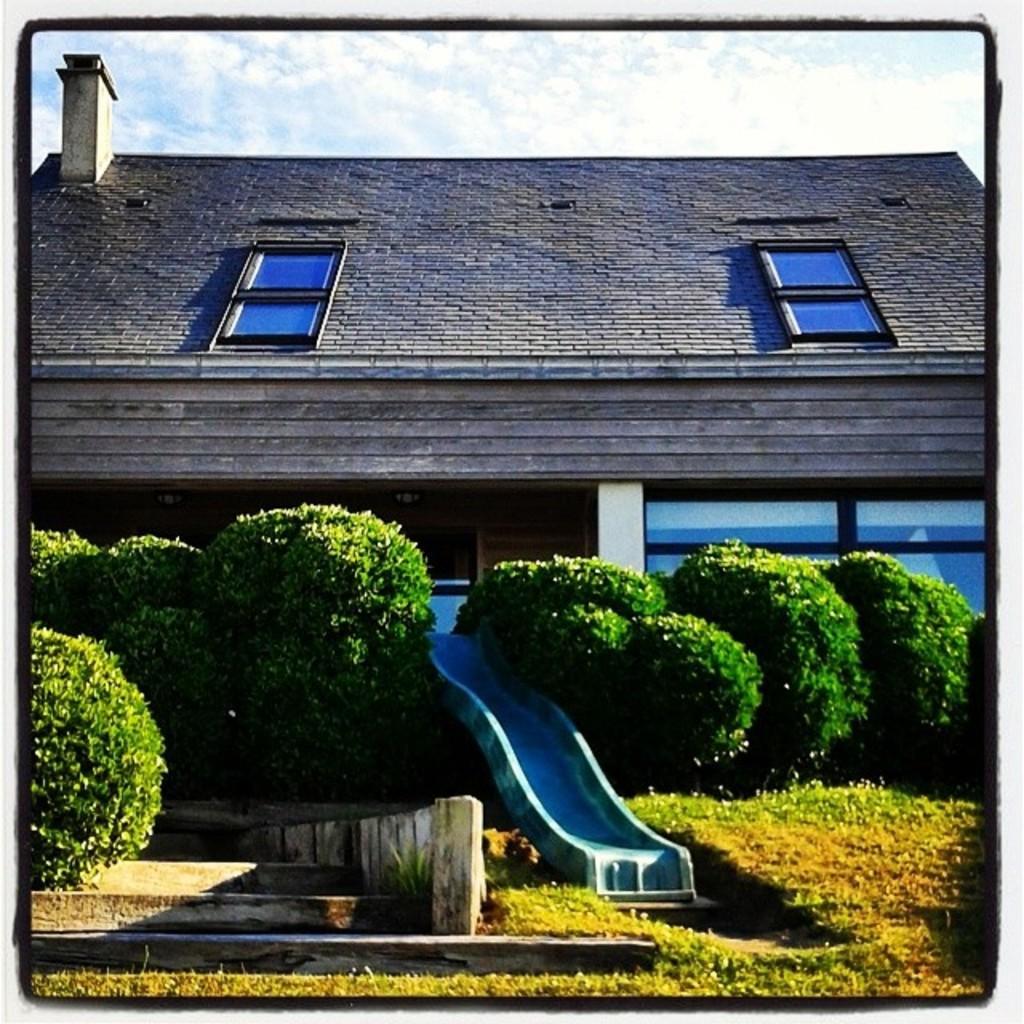In one or two sentences, can you explain what this image depicts? In this picture we can see some plants at the bottom, on the left side there are stars, we can see a slider in the middle, in the background there is a house, we can see the sky at the top of the picture. 